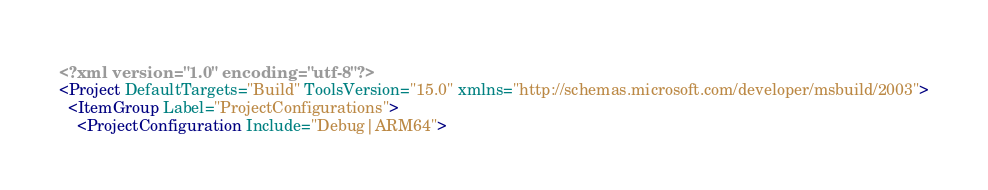<code> <loc_0><loc_0><loc_500><loc_500><_XML_><?xml version="1.0" encoding="utf-8"?>
<Project DefaultTargets="Build" ToolsVersion="15.0" xmlns="http://schemas.microsoft.com/developer/msbuild/2003">
  <ItemGroup Label="ProjectConfigurations">
    <ProjectConfiguration Include="Debug|ARM64"></code> 